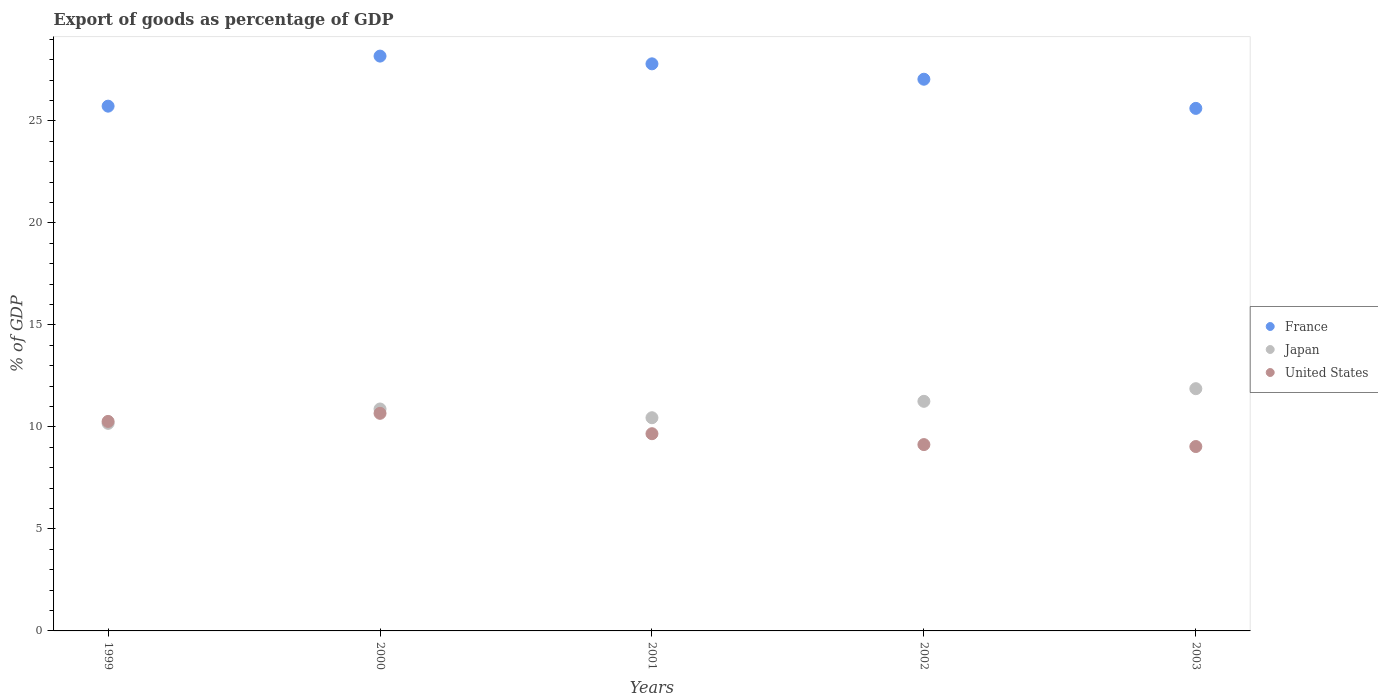How many different coloured dotlines are there?
Give a very brief answer. 3. What is the export of goods as percentage of GDP in Japan in 2000?
Ensure brevity in your answer.  10.88. Across all years, what is the maximum export of goods as percentage of GDP in Japan?
Ensure brevity in your answer.  11.87. Across all years, what is the minimum export of goods as percentage of GDP in Japan?
Provide a succinct answer. 10.17. In which year was the export of goods as percentage of GDP in United States maximum?
Provide a short and direct response. 2000. What is the total export of goods as percentage of GDP in Japan in the graph?
Give a very brief answer. 54.63. What is the difference between the export of goods as percentage of GDP in United States in 2001 and that in 2003?
Your response must be concise. 0.63. What is the difference between the export of goods as percentage of GDP in Japan in 2002 and the export of goods as percentage of GDP in France in 2003?
Ensure brevity in your answer.  -14.36. What is the average export of goods as percentage of GDP in France per year?
Keep it short and to the point. 26.87. In the year 2001, what is the difference between the export of goods as percentage of GDP in Japan and export of goods as percentage of GDP in France?
Your answer should be very brief. -17.35. What is the ratio of the export of goods as percentage of GDP in Japan in 1999 to that in 2000?
Keep it short and to the point. 0.94. Is the export of goods as percentage of GDP in Japan in 1999 less than that in 2000?
Provide a short and direct response. Yes. Is the difference between the export of goods as percentage of GDP in Japan in 2002 and 2003 greater than the difference between the export of goods as percentage of GDP in France in 2002 and 2003?
Your answer should be compact. No. What is the difference between the highest and the second highest export of goods as percentage of GDP in Japan?
Keep it short and to the point. 0.62. What is the difference between the highest and the lowest export of goods as percentage of GDP in Japan?
Make the answer very short. 1.7. Does the export of goods as percentage of GDP in Japan monotonically increase over the years?
Provide a short and direct response. No. Is the export of goods as percentage of GDP in France strictly less than the export of goods as percentage of GDP in United States over the years?
Offer a very short reply. No. How many dotlines are there?
Provide a short and direct response. 3. How many years are there in the graph?
Provide a succinct answer. 5. What is the difference between two consecutive major ticks on the Y-axis?
Offer a very short reply. 5. Are the values on the major ticks of Y-axis written in scientific E-notation?
Offer a terse response. No. How many legend labels are there?
Provide a short and direct response. 3. What is the title of the graph?
Your answer should be compact. Export of goods as percentage of GDP. Does "Andorra" appear as one of the legend labels in the graph?
Ensure brevity in your answer.  No. What is the label or title of the X-axis?
Keep it short and to the point. Years. What is the label or title of the Y-axis?
Offer a terse response. % of GDP. What is the % of GDP of France in 1999?
Keep it short and to the point. 25.72. What is the % of GDP in Japan in 1999?
Make the answer very short. 10.17. What is the % of GDP in United States in 1999?
Your response must be concise. 10.27. What is the % of GDP in France in 2000?
Provide a succinct answer. 28.17. What is the % of GDP in Japan in 2000?
Offer a terse response. 10.88. What is the % of GDP in United States in 2000?
Your response must be concise. 10.66. What is the % of GDP of France in 2001?
Provide a succinct answer. 27.79. What is the % of GDP of Japan in 2001?
Your answer should be compact. 10.45. What is the % of GDP of United States in 2001?
Make the answer very short. 9.67. What is the % of GDP in France in 2002?
Your answer should be compact. 27.04. What is the % of GDP of Japan in 2002?
Offer a terse response. 11.25. What is the % of GDP in United States in 2002?
Keep it short and to the point. 9.13. What is the % of GDP of France in 2003?
Keep it short and to the point. 25.61. What is the % of GDP in Japan in 2003?
Ensure brevity in your answer.  11.87. What is the % of GDP of United States in 2003?
Your answer should be very brief. 9.04. Across all years, what is the maximum % of GDP of France?
Your answer should be compact. 28.17. Across all years, what is the maximum % of GDP in Japan?
Your response must be concise. 11.87. Across all years, what is the maximum % of GDP of United States?
Your response must be concise. 10.66. Across all years, what is the minimum % of GDP of France?
Make the answer very short. 25.61. Across all years, what is the minimum % of GDP of Japan?
Make the answer very short. 10.17. Across all years, what is the minimum % of GDP of United States?
Your answer should be very brief. 9.04. What is the total % of GDP in France in the graph?
Your response must be concise. 134.34. What is the total % of GDP of Japan in the graph?
Provide a short and direct response. 54.63. What is the total % of GDP of United States in the graph?
Ensure brevity in your answer.  48.77. What is the difference between the % of GDP of France in 1999 and that in 2000?
Provide a short and direct response. -2.45. What is the difference between the % of GDP of Japan in 1999 and that in 2000?
Provide a short and direct response. -0.7. What is the difference between the % of GDP of United States in 1999 and that in 2000?
Make the answer very short. -0.4. What is the difference between the % of GDP in France in 1999 and that in 2001?
Offer a terse response. -2.07. What is the difference between the % of GDP of Japan in 1999 and that in 2001?
Give a very brief answer. -0.28. What is the difference between the % of GDP in United States in 1999 and that in 2001?
Your answer should be very brief. 0.6. What is the difference between the % of GDP in France in 1999 and that in 2002?
Your answer should be compact. -1.32. What is the difference between the % of GDP in Japan in 1999 and that in 2002?
Offer a terse response. -1.08. What is the difference between the % of GDP in United States in 1999 and that in 2002?
Offer a terse response. 1.14. What is the difference between the % of GDP in France in 1999 and that in 2003?
Offer a very short reply. 0.11. What is the difference between the % of GDP of Japan in 1999 and that in 2003?
Offer a very short reply. -1.7. What is the difference between the % of GDP in United States in 1999 and that in 2003?
Provide a short and direct response. 1.23. What is the difference between the % of GDP in France in 2000 and that in 2001?
Offer a very short reply. 0.38. What is the difference between the % of GDP in Japan in 2000 and that in 2001?
Your response must be concise. 0.43. What is the difference between the % of GDP in United States in 2000 and that in 2001?
Make the answer very short. 1. What is the difference between the % of GDP in France in 2000 and that in 2002?
Make the answer very short. 1.13. What is the difference between the % of GDP of Japan in 2000 and that in 2002?
Offer a very short reply. -0.38. What is the difference between the % of GDP of United States in 2000 and that in 2002?
Make the answer very short. 1.53. What is the difference between the % of GDP in France in 2000 and that in 2003?
Provide a short and direct response. 2.56. What is the difference between the % of GDP of Japan in 2000 and that in 2003?
Offer a terse response. -1. What is the difference between the % of GDP of United States in 2000 and that in 2003?
Ensure brevity in your answer.  1.63. What is the difference between the % of GDP in France in 2001 and that in 2002?
Provide a short and direct response. 0.75. What is the difference between the % of GDP of Japan in 2001 and that in 2002?
Your answer should be very brief. -0.8. What is the difference between the % of GDP of United States in 2001 and that in 2002?
Ensure brevity in your answer.  0.53. What is the difference between the % of GDP in France in 2001 and that in 2003?
Make the answer very short. 2.18. What is the difference between the % of GDP in Japan in 2001 and that in 2003?
Give a very brief answer. -1.42. What is the difference between the % of GDP of United States in 2001 and that in 2003?
Your response must be concise. 0.63. What is the difference between the % of GDP of France in 2002 and that in 2003?
Offer a very short reply. 1.43. What is the difference between the % of GDP in Japan in 2002 and that in 2003?
Ensure brevity in your answer.  -0.62. What is the difference between the % of GDP of United States in 2002 and that in 2003?
Your response must be concise. 0.09. What is the difference between the % of GDP of France in 1999 and the % of GDP of Japan in 2000?
Make the answer very short. 14.84. What is the difference between the % of GDP in France in 1999 and the % of GDP in United States in 2000?
Keep it short and to the point. 15.06. What is the difference between the % of GDP of Japan in 1999 and the % of GDP of United States in 2000?
Your answer should be very brief. -0.49. What is the difference between the % of GDP of France in 1999 and the % of GDP of Japan in 2001?
Offer a terse response. 15.27. What is the difference between the % of GDP of France in 1999 and the % of GDP of United States in 2001?
Give a very brief answer. 16.05. What is the difference between the % of GDP of Japan in 1999 and the % of GDP of United States in 2001?
Ensure brevity in your answer.  0.51. What is the difference between the % of GDP in France in 1999 and the % of GDP in Japan in 2002?
Give a very brief answer. 14.47. What is the difference between the % of GDP of France in 1999 and the % of GDP of United States in 2002?
Give a very brief answer. 16.59. What is the difference between the % of GDP in Japan in 1999 and the % of GDP in United States in 2002?
Ensure brevity in your answer.  1.04. What is the difference between the % of GDP in France in 1999 and the % of GDP in Japan in 2003?
Provide a succinct answer. 13.85. What is the difference between the % of GDP of France in 1999 and the % of GDP of United States in 2003?
Provide a short and direct response. 16.68. What is the difference between the % of GDP in Japan in 1999 and the % of GDP in United States in 2003?
Offer a very short reply. 1.14. What is the difference between the % of GDP in France in 2000 and the % of GDP in Japan in 2001?
Keep it short and to the point. 17.72. What is the difference between the % of GDP in France in 2000 and the % of GDP in United States in 2001?
Provide a short and direct response. 18.51. What is the difference between the % of GDP of Japan in 2000 and the % of GDP of United States in 2001?
Your answer should be very brief. 1.21. What is the difference between the % of GDP in France in 2000 and the % of GDP in Japan in 2002?
Offer a terse response. 16.92. What is the difference between the % of GDP in France in 2000 and the % of GDP in United States in 2002?
Provide a succinct answer. 19.04. What is the difference between the % of GDP in Japan in 2000 and the % of GDP in United States in 2002?
Ensure brevity in your answer.  1.75. What is the difference between the % of GDP in France in 2000 and the % of GDP in Japan in 2003?
Keep it short and to the point. 16.3. What is the difference between the % of GDP in France in 2000 and the % of GDP in United States in 2003?
Give a very brief answer. 19.14. What is the difference between the % of GDP in Japan in 2000 and the % of GDP in United States in 2003?
Your answer should be compact. 1.84. What is the difference between the % of GDP in France in 2001 and the % of GDP in Japan in 2002?
Give a very brief answer. 16.54. What is the difference between the % of GDP of France in 2001 and the % of GDP of United States in 2002?
Offer a terse response. 18.66. What is the difference between the % of GDP of Japan in 2001 and the % of GDP of United States in 2002?
Your response must be concise. 1.32. What is the difference between the % of GDP of France in 2001 and the % of GDP of Japan in 2003?
Provide a succinct answer. 15.92. What is the difference between the % of GDP of France in 2001 and the % of GDP of United States in 2003?
Your answer should be very brief. 18.76. What is the difference between the % of GDP in Japan in 2001 and the % of GDP in United States in 2003?
Provide a short and direct response. 1.41. What is the difference between the % of GDP in France in 2002 and the % of GDP in Japan in 2003?
Your response must be concise. 15.17. What is the difference between the % of GDP in France in 2002 and the % of GDP in United States in 2003?
Give a very brief answer. 18. What is the difference between the % of GDP in Japan in 2002 and the % of GDP in United States in 2003?
Your answer should be very brief. 2.22. What is the average % of GDP of France per year?
Offer a terse response. 26.87. What is the average % of GDP of Japan per year?
Provide a short and direct response. 10.93. What is the average % of GDP of United States per year?
Give a very brief answer. 9.75. In the year 1999, what is the difference between the % of GDP of France and % of GDP of Japan?
Offer a very short reply. 15.55. In the year 1999, what is the difference between the % of GDP in France and % of GDP in United States?
Provide a short and direct response. 15.45. In the year 1999, what is the difference between the % of GDP in Japan and % of GDP in United States?
Your answer should be very brief. -0.09. In the year 2000, what is the difference between the % of GDP in France and % of GDP in Japan?
Provide a succinct answer. 17.3. In the year 2000, what is the difference between the % of GDP of France and % of GDP of United States?
Provide a short and direct response. 17.51. In the year 2000, what is the difference between the % of GDP in Japan and % of GDP in United States?
Offer a terse response. 0.21. In the year 2001, what is the difference between the % of GDP of France and % of GDP of Japan?
Keep it short and to the point. 17.35. In the year 2001, what is the difference between the % of GDP in France and % of GDP in United States?
Ensure brevity in your answer.  18.13. In the year 2001, what is the difference between the % of GDP of Japan and % of GDP of United States?
Give a very brief answer. 0.78. In the year 2002, what is the difference between the % of GDP of France and % of GDP of Japan?
Your answer should be compact. 15.79. In the year 2002, what is the difference between the % of GDP in France and % of GDP in United States?
Keep it short and to the point. 17.91. In the year 2002, what is the difference between the % of GDP in Japan and % of GDP in United States?
Provide a succinct answer. 2.12. In the year 2003, what is the difference between the % of GDP in France and % of GDP in Japan?
Provide a short and direct response. 13.74. In the year 2003, what is the difference between the % of GDP of France and % of GDP of United States?
Provide a succinct answer. 16.57. In the year 2003, what is the difference between the % of GDP of Japan and % of GDP of United States?
Offer a terse response. 2.84. What is the ratio of the % of GDP in France in 1999 to that in 2000?
Your answer should be compact. 0.91. What is the ratio of the % of GDP of Japan in 1999 to that in 2000?
Your answer should be very brief. 0.94. What is the ratio of the % of GDP in United States in 1999 to that in 2000?
Your answer should be very brief. 0.96. What is the ratio of the % of GDP in France in 1999 to that in 2001?
Provide a succinct answer. 0.93. What is the ratio of the % of GDP of Japan in 1999 to that in 2001?
Provide a short and direct response. 0.97. What is the ratio of the % of GDP in United States in 1999 to that in 2001?
Make the answer very short. 1.06. What is the ratio of the % of GDP of France in 1999 to that in 2002?
Your answer should be compact. 0.95. What is the ratio of the % of GDP in Japan in 1999 to that in 2002?
Your response must be concise. 0.9. What is the ratio of the % of GDP of United States in 1999 to that in 2002?
Your response must be concise. 1.12. What is the ratio of the % of GDP in France in 1999 to that in 2003?
Provide a succinct answer. 1. What is the ratio of the % of GDP of Japan in 1999 to that in 2003?
Offer a terse response. 0.86. What is the ratio of the % of GDP of United States in 1999 to that in 2003?
Your response must be concise. 1.14. What is the ratio of the % of GDP of France in 2000 to that in 2001?
Give a very brief answer. 1.01. What is the ratio of the % of GDP in Japan in 2000 to that in 2001?
Provide a short and direct response. 1.04. What is the ratio of the % of GDP of United States in 2000 to that in 2001?
Your response must be concise. 1.1. What is the ratio of the % of GDP in France in 2000 to that in 2002?
Provide a succinct answer. 1.04. What is the ratio of the % of GDP in Japan in 2000 to that in 2002?
Give a very brief answer. 0.97. What is the ratio of the % of GDP in United States in 2000 to that in 2002?
Your answer should be very brief. 1.17. What is the ratio of the % of GDP in France in 2000 to that in 2003?
Ensure brevity in your answer.  1.1. What is the ratio of the % of GDP of Japan in 2000 to that in 2003?
Your answer should be very brief. 0.92. What is the ratio of the % of GDP of United States in 2000 to that in 2003?
Offer a terse response. 1.18. What is the ratio of the % of GDP in France in 2001 to that in 2002?
Make the answer very short. 1.03. What is the ratio of the % of GDP of Japan in 2001 to that in 2002?
Offer a terse response. 0.93. What is the ratio of the % of GDP in United States in 2001 to that in 2002?
Your answer should be compact. 1.06. What is the ratio of the % of GDP in France in 2001 to that in 2003?
Provide a short and direct response. 1.09. What is the ratio of the % of GDP in Japan in 2001 to that in 2003?
Your response must be concise. 0.88. What is the ratio of the % of GDP of United States in 2001 to that in 2003?
Your answer should be very brief. 1.07. What is the ratio of the % of GDP in France in 2002 to that in 2003?
Give a very brief answer. 1.06. What is the ratio of the % of GDP of Japan in 2002 to that in 2003?
Keep it short and to the point. 0.95. What is the ratio of the % of GDP of United States in 2002 to that in 2003?
Ensure brevity in your answer.  1.01. What is the difference between the highest and the second highest % of GDP of France?
Your response must be concise. 0.38. What is the difference between the highest and the second highest % of GDP of Japan?
Your answer should be very brief. 0.62. What is the difference between the highest and the second highest % of GDP of United States?
Your answer should be very brief. 0.4. What is the difference between the highest and the lowest % of GDP of France?
Your response must be concise. 2.56. What is the difference between the highest and the lowest % of GDP in Japan?
Offer a very short reply. 1.7. What is the difference between the highest and the lowest % of GDP in United States?
Provide a succinct answer. 1.63. 